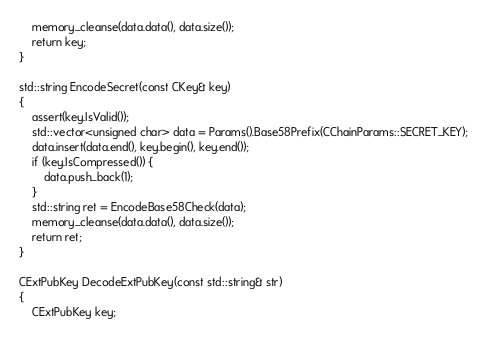Convert code to text. <code><loc_0><loc_0><loc_500><loc_500><_C++_>    memory_cleanse(data.data(), data.size());
    return key;
}

std::string EncodeSecret(const CKey& key)
{
    assert(key.IsValid());
    std::vector<unsigned char> data = Params().Base58Prefix(CChainParams::SECRET_KEY);
    data.insert(data.end(), key.begin(), key.end());
    if (key.IsCompressed()) {
        data.push_back(1);
    }
    std::string ret = EncodeBase58Check(data);
    memory_cleanse(data.data(), data.size());
    return ret;
}

CExtPubKey DecodeExtPubKey(const std::string& str)
{
    CExtPubKey key;</code> 